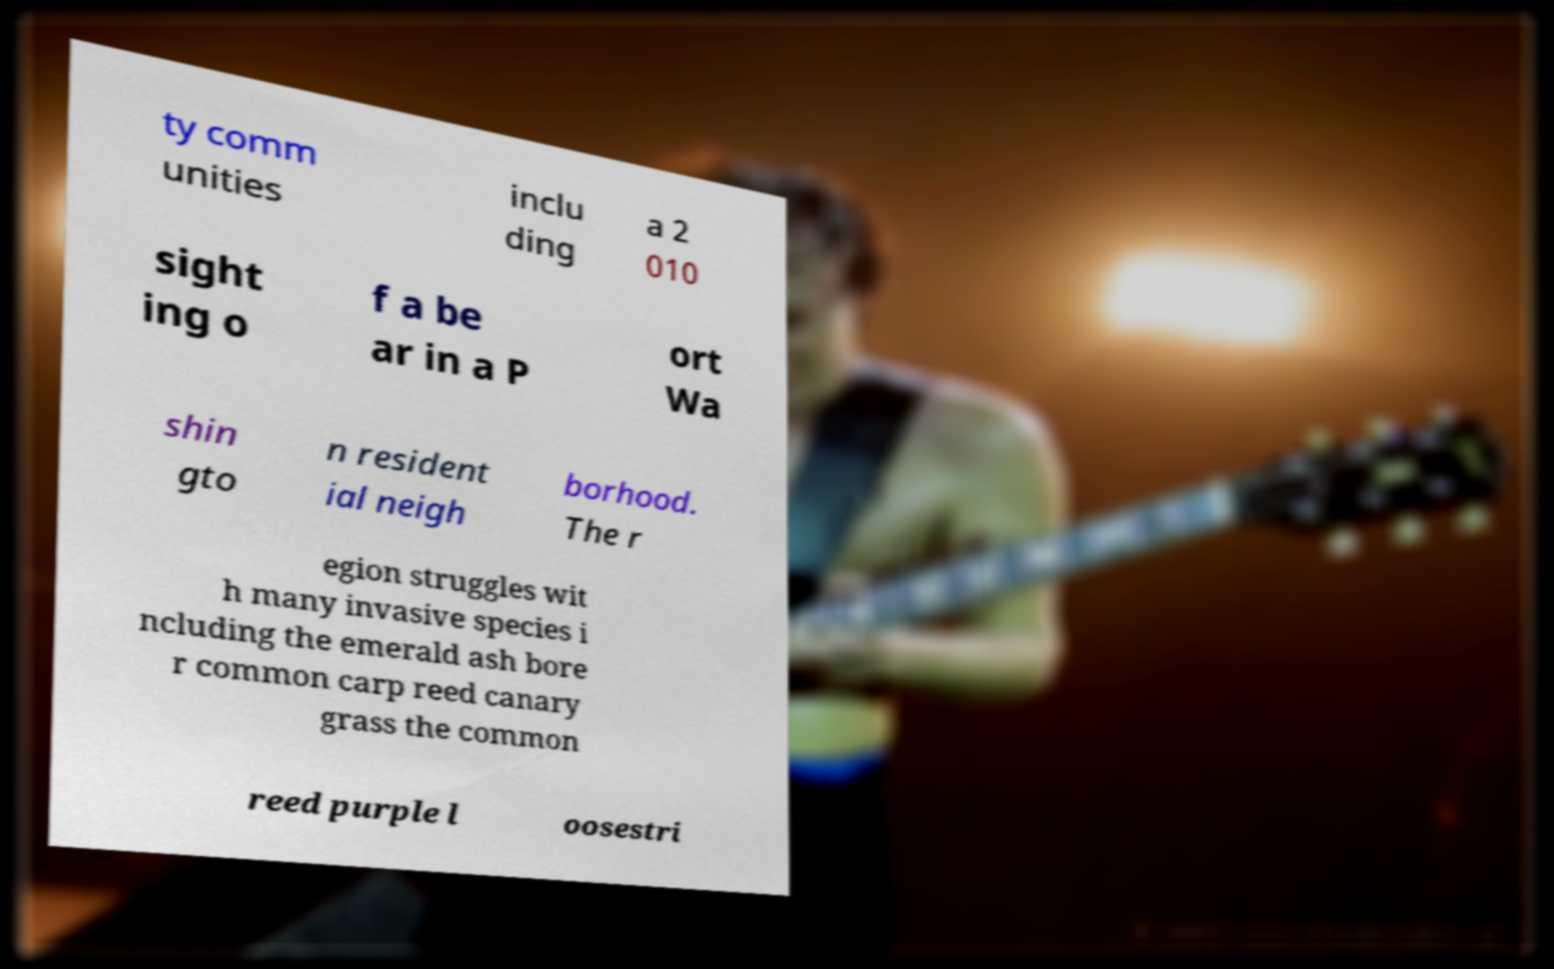I need the written content from this picture converted into text. Can you do that? ty comm unities inclu ding a 2 010 sight ing o f a be ar in a P ort Wa shin gto n resident ial neigh borhood. The r egion struggles wit h many invasive species i ncluding the emerald ash bore r common carp reed canary grass the common reed purple l oosestri 